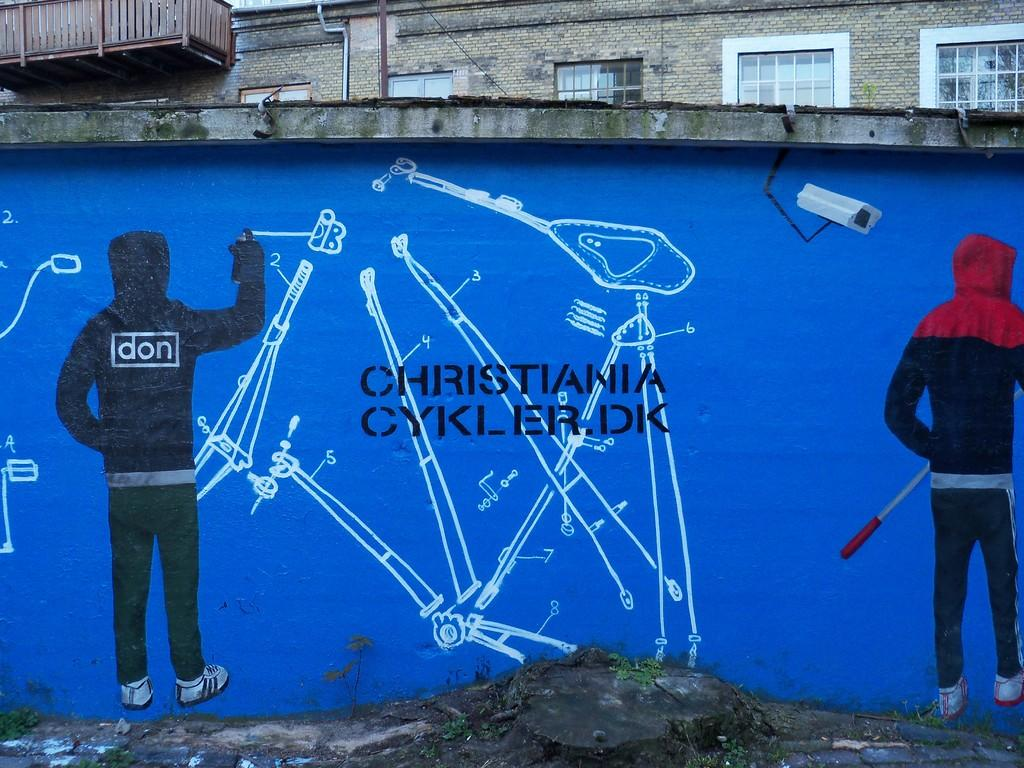What is depicted in the painting in the image? There is a painting of two persons in the image. What type of security device is present in the image? There is a CCTV camera in the image. What can be seen on the wall in the image? There are words and objects on the wall in the image. What is visible behind the wall in the image? There is a building behind the wall in the image. What architectural features can be seen on the building in the image? There is a pipe, windows, and a balcony visible on the building in the image. What is the weight of the train passing by in the image? There is no train present in the image, so it is not possible to determine its weight. What time is displayed on the clock in the image? There is no clock present in the image, so it is not possible to determine the time. 